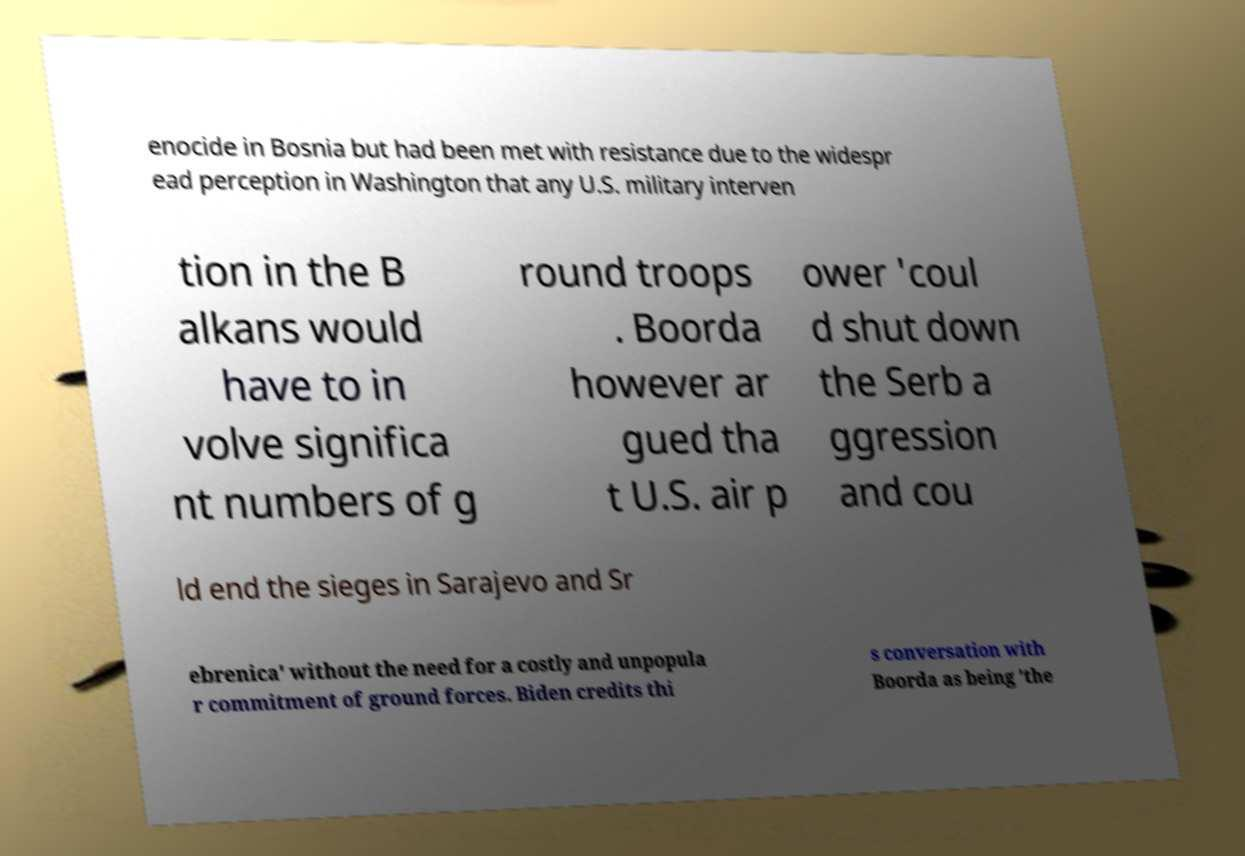Can you accurately transcribe the text from the provided image for me? enocide in Bosnia but had been met with resistance due to the widespr ead perception in Washington that any U.S. military interven tion in the B alkans would have to in volve significa nt numbers of g round troops . Boorda however ar gued tha t U.S. air p ower 'coul d shut down the Serb a ggression and cou ld end the sieges in Sarajevo and Sr ebrenica' without the need for a costly and unpopula r commitment of ground forces. Biden credits thi s conversation with Boorda as being 'the 